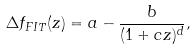<formula> <loc_0><loc_0><loc_500><loc_500>\Delta f _ { F I T } ( z ) = a - \frac { b } { ( 1 + c z ) ^ { d } } ,</formula> 